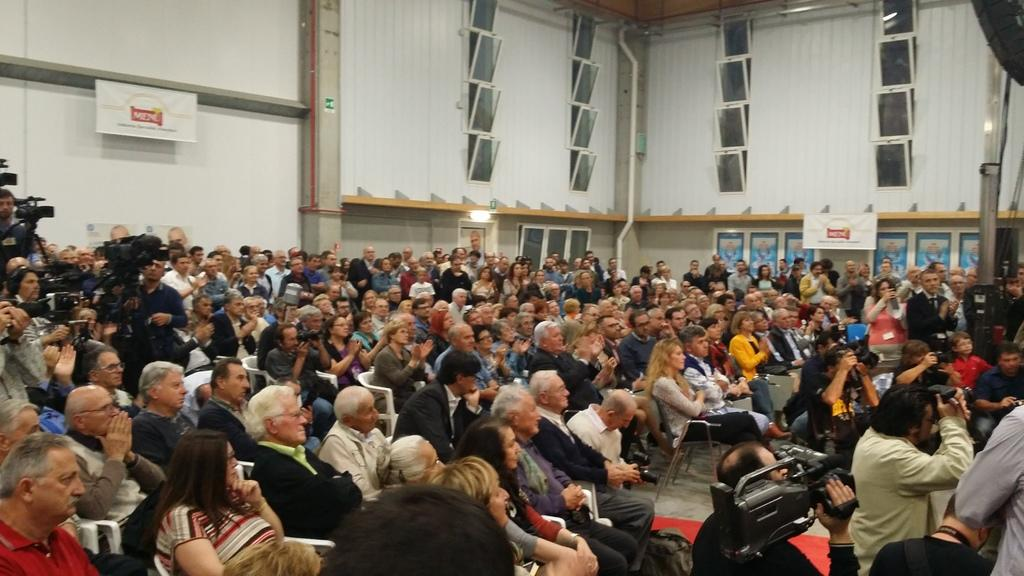What are the people in the center of the image doing? There are people sitting in the center of the image. What are the people on the left side of the image doing? The people standing on the left side of the image are holding cameras in their hands. What can be seen in the background of the image? There are windows and a wall visible in the background of the image. What type of book is the person reading on the right side of the image? There is no person reading a book on the right side of the image. How does the fork fall from the person's hand in the image? There is no fork or person dropping it in the image. 